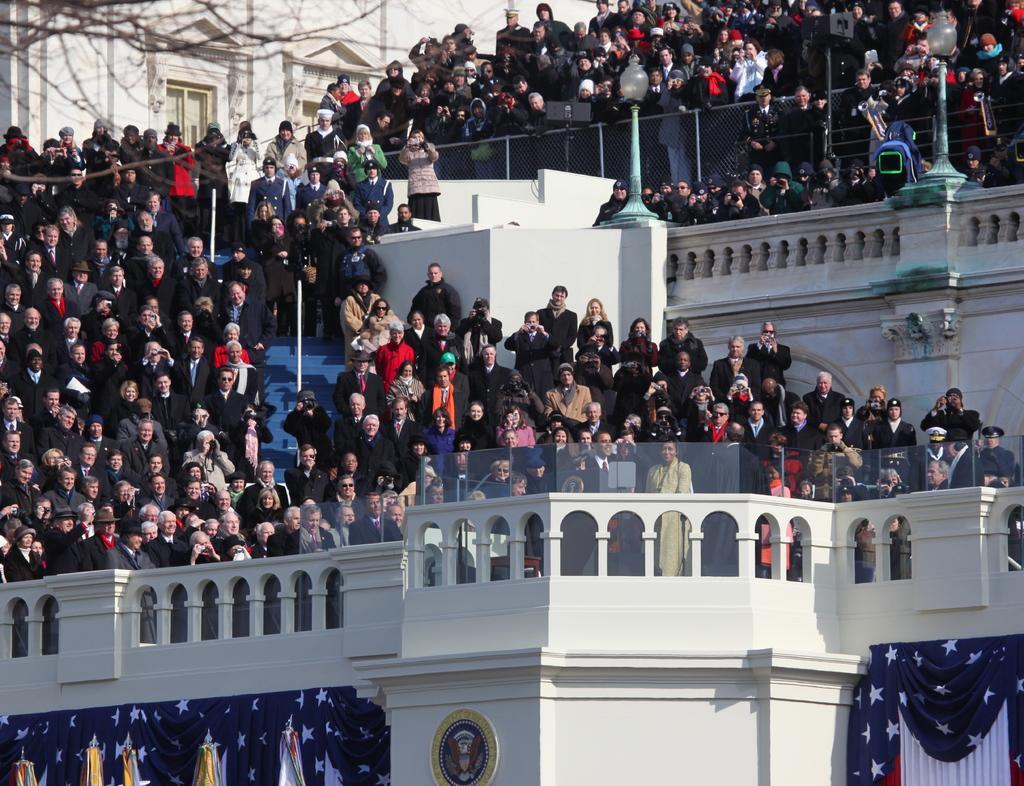Describe this image in one or two sentences. In this picture we can see a group of people, building, fence, tree, poles, flags and some objects. 